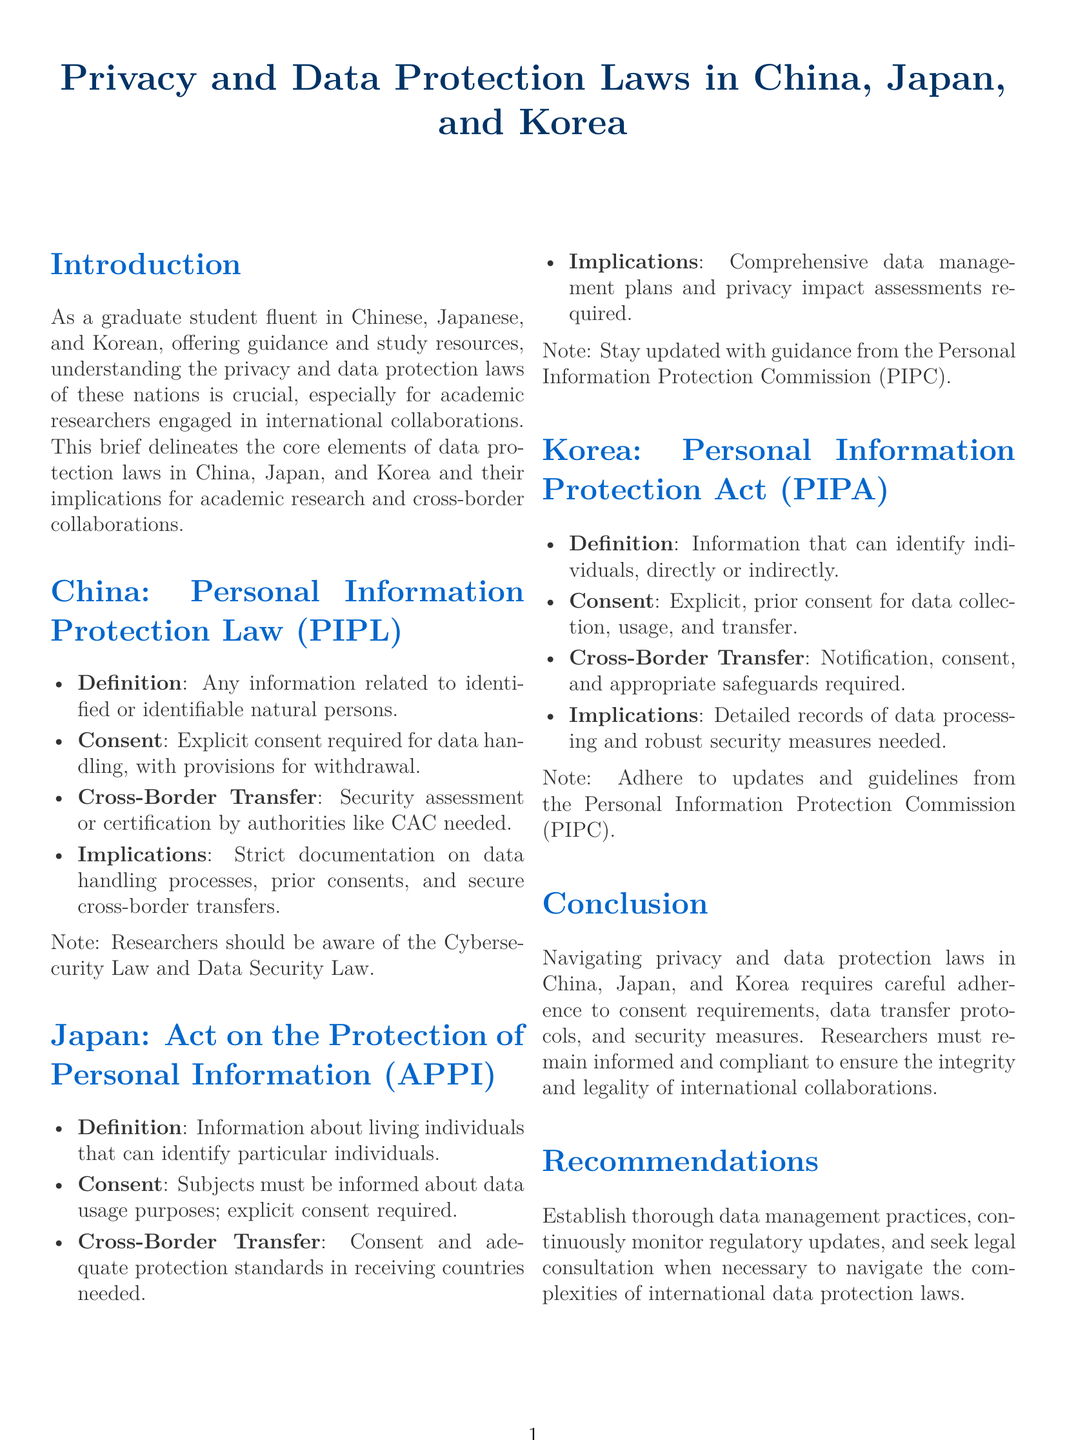What is the title of the document? The title of the document is presented in the title section, which outlines the focus on privacy and data protection laws in specific countries.
Answer: Privacy and Data Protection Laws in China, Japan, and Korea What law governs personal information protection in China? The document identifies the specific law related to personal information protection in China.
Answer: Personal Information Protection Law (PIPL) What type of consent is required for data handling under China's PIPL? The document specifies the type of consent needed for data handling under the PIPL.
Answer: Explicit consent What is required for cross-border transfer of data in Japan? The requirements for cross-border data transfer in Japan are outlined, specifically about consent and standards.
Answer: Consent and adequate protection standards Which commission provides guidance in Japan regarding personal information protection? The document mentions an organization that oversees personal information protection in Japan.
Answer: Personal Information Protection Commission (PIPC) What type of consent is necessary for data collection in Korea? The type of consent required for data collection under Korea's law is specified in the document.
Answer: Explicit, prior consent Name one implication for academic researchers under China's privacy law. The implications for academic researchers working under China's privacy law are detailed; one aspect is noted.
Answer: Strict documentation on data handling processes What legislative act governs personal information protection in Korea? The document provides the name of the law that governs personal information in Korea.
Answer: Personal Information Protection Act (PIPA) What is a required component of data management plans in Japan? The document specifies an essential element that should be included in data management plans in Japan.
Answer: Privacy impact assessments 